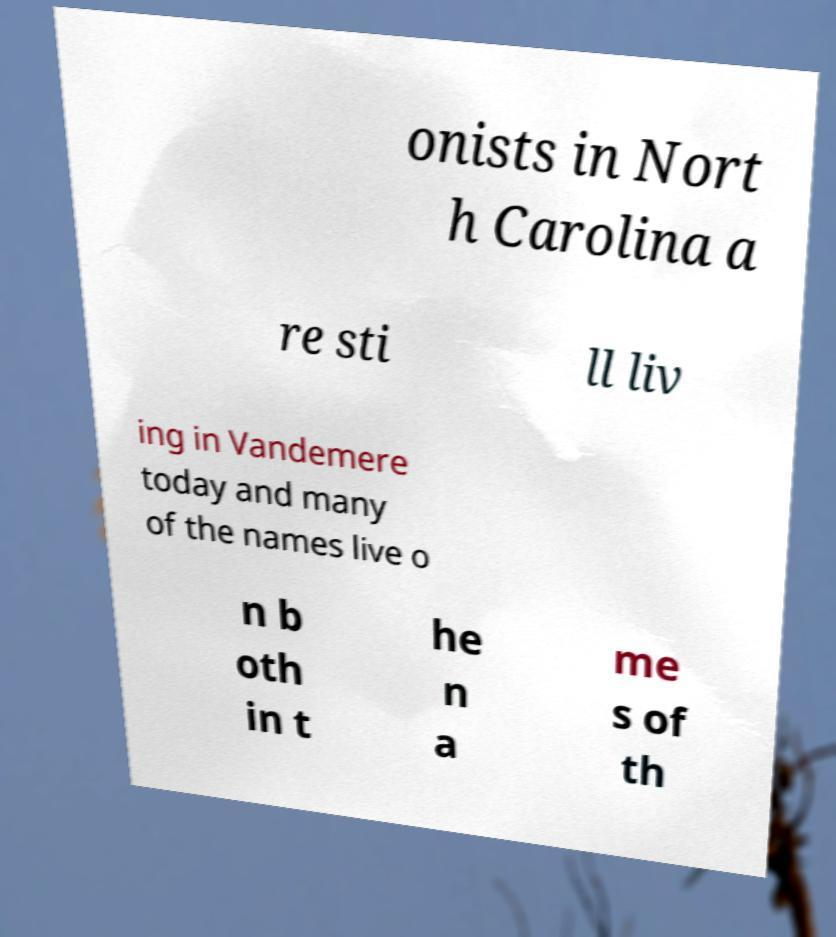Can you accurately transcribe the text from the provided image for me? onists in Nort h Carolina a re sti ll liv ing in Vandemere today and many of the names live o n b oth in t he n a me s of th 